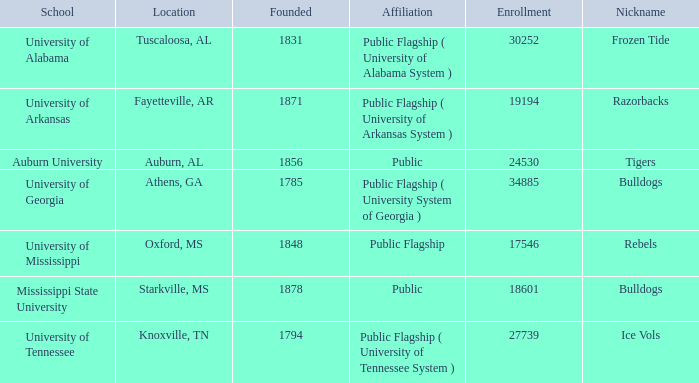Parse the table in full. {'header': ['School', 'Location', 'Founded', 'Affiliation', 'Enrollment', 'Nickname'], 'rows': [['University of Alabama', 'Tuscaloosa, AL', '1831', 'Public Flagship ( University of Alabama System )', '30252', 'Frozen Tide'], ['University of Arkansas', 'Fayetteville, AR', '1871', 'Public Flagship ( University of Arkansas System )', '19194', 'Razorbacks'], ['Auburn University', 'Auburn, AL', '1856', 'Public', '24530', 'Tigers'], ['University of Georgia', 'Athens, GA', '1785', 'Public Flagship ( University System of Georgia )', '34885', 'Bulldogs'], ['University of Mississippi', 'Oxford, MS', '1848', 'Public Flagship', '17546', 'Rebels'], ['Mississippi State University', 'Starkville, MS', '1878', 'Public', '18601', 'Bulldogs'], ['University of Tennessee', 'Knoxville, TN', '1794', 'Public Flagship ( University of Tennessee System )', '27739', 'Ice Vols']]} What is the nickname of the University of Alabama? Frozen Tide. 